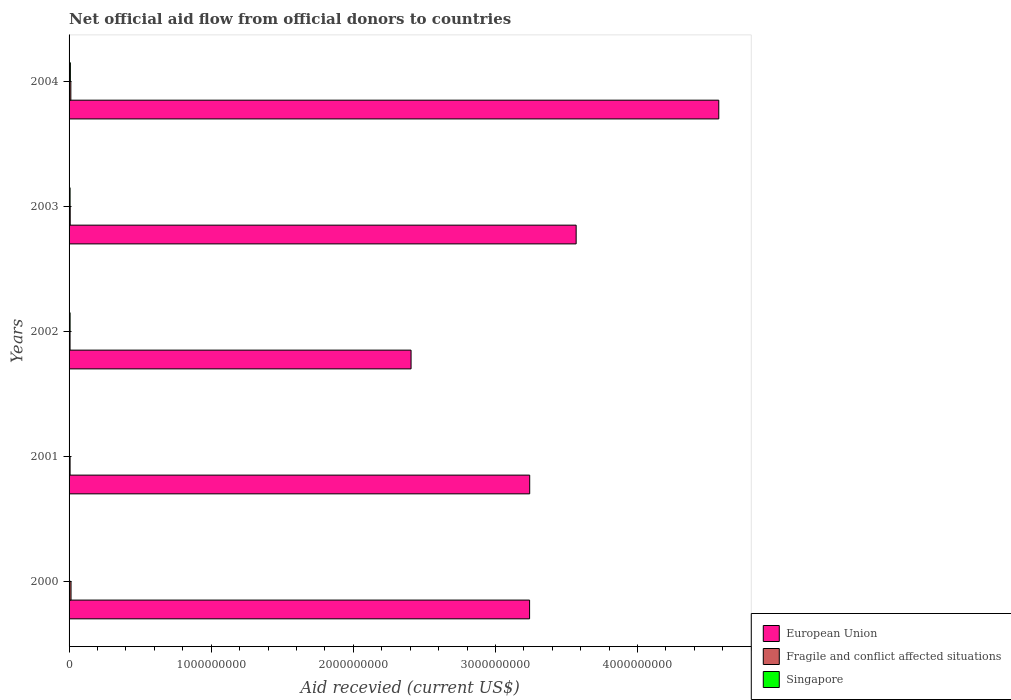Are the number of bars per tick equal to the number of legend labels?
Your answer should be compact. Yes. How many bars are there on the 2nd tick from the top?
Your answer should be very brief. 3. What is the total aid received in Fragile and conflict affected situations in 2004?
Your answer should be compact. 1.24e+07. Across all years, what is the maximum total aid received in European Union?
Your response must be concise. 4.57e+09. Across all years, what is the minimum total aid received in Fragile and conflict affected situations?
Your answer should be very brief. 6.88e+06. In which year was the total aid received in European Union maximum?
Your response must be concise. 2004. In which year was the total aid received in European Union minimum?
Your response must be concise. 2002. What is the total total aid received in Singapore in the graph?
Offer a terse response. 2.53e+07. What is the difference between the total aid received in European Union in 2000 and that in 2003?
Your answer should be compact. -3.28e+08. What is the difference between the total aid received in Fragile and conflict affected situations in 2000 and the total aid received in Singapore in 2003?
Ensure brevity in your answer.  6.68e+06. What is the average total aid received in Singapore per year?
Offer a terse response. 5.07e+06. In the year 2001, what is the difference between the total aid received in Singapore and total aid received in European Union?
Offer a terse response. -3.24e+09. What is the ratio of the total aid received in Singapore in 2001 to that in 2004?
Offer a terse response. 0.09. Is the total aid received in Fragile and conflict affected situations in 2000 less than that in 2002?
Ensure brevity in your answer.  No. Is the difference between the total aid received in Singapore in 2001 and 2004 greater than the difference between the total aid received in European Union in 2001 and 2004?
Make the answer very short. Yes. What is the difference between the highest and the second highest total aid received in European Union?
Ensure brevity in your answer.  1.00e+09. What is the difference between the highest and the lowest total aid received in Singapore?
Your answer should be compact. 8.29e+06. What does the 1st bar from the top in 2002 represents?
Give a very brief answer. Singapore. What does the 3rd bar from the bottom in 2003 represents?
Your response must be concise. Singapore. Is it the case that in every year, the sum of the total aid received in Singapore and total aid received in Fragile and conflict affected situations is greater than the total aid received in European Union?
Your answer should be compact. No. How many bars are there?
Keep it short and to the point. 15. What is the difference between two consecutive major ticks on the X-axis?
Your response must be concise. 1.00e+09. Does the graph contain any zero values?
Provide a short and direct response. No. How are the legend labels stacked?
Make the answer very short. Vertical. What is the title of the graph?
Your answer should be compact. Net official aid flow from official donors to countries. What is the label or title of the X-axis?
Offer a terse response. Aid recevied (current US$). What is the label or title of the Y-axis?
Your answer should be compact. Years. What is the Aid recevied (current US$) in European Union in 2000?
Your answer should be very brief. 3.24e+09. What is the Aid recevied (current US$) of Fragile and conflict affected situations in 2000?
Provide a succinct answer. 1.38e+07. What is the Aid recevied (current US$) in Singapore in 2000?
Your answer should be very brief. 1.09e+06. What is the Aid recevied (current US$) in European Union in 2001?
Offer a very short reply. 3.24e+09. What is the Aid recevied (current US$) in Fragile and conflict affected situations in 2001?
Provide a succinct answer. 7.14e+06. What is the Aid recevied (current US$) of Singapore in 2001?
Make the answer very short. 8.50e+05. What is the Aid recevied (current US$) of European Union in 2002?
Give a very brief answer. 2.41e+09. What is the Aid recevied (current US$) of Fragile and conflict affected situations in 2002?
Provide a short and direct response. 6.88e+06. What is the Aid recevied (current US$) in Singapore in 2002?
Your answer should be compact. 7.19e+06. What is the Aid recevied (current US$) of European Union in 2003?
Make the answer very short. 3.57e+09. What is the Aid recevied (current US$) in Fragile and conflict affected situations in 2003?
Your response must be concise. 7.95e+06. What is the Aid recevied (current US$) in Singapore in 2003?
Your answer should be very brief. 7.07e+06. What is the Aid recevied (current US$) of European Union in 2004?
Your response must be concise. 4.57e+09. What is the Aid recevied (current US$) of Fragile and conflict affected situations in 2004?
Provide a short and direct response. 1.24e+07. What is the Aid recevied (current US$) of Singapore in 2004?
Keep it short and to the point. 9.14e+06. Across all years, what is the maximum Aid recevied (current US$) in European Union?
Offer a very short reply. 4.57e+09. Across all years, what is the maximum Aid recevied (current US$) of Fragile and conflict affected situations?
Provide a short and direct response. 1.38e+07. Across all years, what is the maximum Aid recevied (current US$) of Singapore?
Ensure brevity in your answer.  9.14e+06. Across all years, what is the minimum Aid recevied (current US$) of European Union?
Offer a very short reply. 2.41e+09. Across all years, what is the minimum Aid recevied (current US$) in Fragile and conflict affected situations?
Your response must be concise. 6.88e+06. Across all years, what is the minimum Aid recevied (current US$) of Singapore?
Your answer should be compact. 8.50e+05. What is the total Aid recevied (current US$) in European Union in the graph?
Provide a short and direct response. 1.70e+1. What is the total Aid recevied (current US$) in Fragile and conflict affected situations in the graph?
Give a very brief answer. 4.82e+07. What is the total Aid recevied (current US$) in Singapore in the graph?
Make the answer very short. 2.53e+07. What is the difference between the Aid recevied (current US$) of European Union in 2000 and that in 2001?
Keep it short and to the point. -7.70e+05. What is the difference between the Aid recevied (current US$) in Fragile and conflict affected situations in 2000 and that in 2001?
Give a very brief answer. 6.61e+06. What is the difference between the Aid recevied (current US$) in Singapore in 2000 and that in 2001?
Your answer should be compact. 2.40e+05. What is the difference between the Aid recevied (current US$) in European Union in 2000 and that in 2002?
Offer a very short reply. 8.34e+08. What is the difference between the Aid recevied (current US$) in Fragile and conflict affected situations in 2000 and that in 2002?
Your response must be concise. 6.87e+06. What is the difference between the Aid recevied (current US$) in Singapore in 2000 and that in 2002?
Your answer should be very brief. -6.10e+06. What is the difference between the Aid recevied (current US$) of European Union in 2000 and that in 2003?
Provide a short and direct response. -3.28e+08. What is the difference between the Aid recevied (current US$) of Fragile and conflict affected situations in 2000 and that in 2003?
Offer a very short reply. 5.80e+06. What is the difference between the Aid recevied (current US$) in Singapore in 2000 and that in 2003?
Your response must be concise. -5.98e+06. What is the difference between the Aid recevied (current US$) of European Union in 2000 and that in 2004?
Offer a very short reply. -1.33e+09. What is the difference between the Aid recevied (current US$) in Fragile and conflict affected situations in 2000 and that in 2004?
Make the answer very short. 1.32e+06. What is the difference between the Aid recevied (current US$) of Singapore in 2000 and that in 2004?
Offer a terse response. -8.05e+06. What is the difference between the Aid recevied (current US$) in European Union in 2001 and that in 2002?
Offer a very short reply. 8.35e+08. What is the difference between the Aid recevied (current US$) in Fragile and conflict affected situations in 2001 and that in 2002?
Your response must be concise. 2.60e+05. What is the difference between the Aid recevied (current US$) of Singapore in 2001 and that in 2002?
Ensure brevity in your answer.  -6.34e+06. What is the difference between the Aid recevied (current US$) of European Union in 2001 and that in 2003?
Your answer should be very brief. -3.27e+08. What is the difference between the Aid recevied (current US$) in Fragile and conflict affected situations in 2001 and that in 2003?
Make the answer very short. -8.10e+05. What is the difference between the Aid recevied (current US$) of Singapore in 2001 and that in 2003?
Provide a short and direct response. -6.22e+06. What is the difference between the Aid recevied (current US$) in European Union in 2001 and that in 2004?
Give a very brief answer. -1.33e+09. What is the difference between the Aid recevied (current US$) of Fragile and conflict affected situations in 2001 and that in 2004?
Your response must be concise. -5.29e+06. What is the difference between the Aid recevied (current US$) in Singapore in 2001 and that in 2004?
Your response must be concise. -8.29e+06. What is the difference between the Aid recevied (current US$) of European Union in 2002 and that in 2003?
Provide a succinct answer. -1.16e+09. What is the difference between the Aid recevied (current US$) in Fragile and conflict affected situations in 2002 and that in 2003?
Offer a very short reply. -1.07e+06. What is the difference between the Aid recevied (current US$) in Singapore in 2002 and that in 2003?
Ensure brevity in your answer.  1.20e+05. What is the difference between the Aid recevied (current US$) of European Union in 2002 and that in 2004?
Ensure brevity in your answer.  -2.17e+09. What is the difference between the Aid recevied (current US$) in Fragile and conflict affected situations in 2002 and that in 2004?
Make the answer very short. -5.55e+06. What is the difference between the Aid recevied (current US$) of Singapore in 2002 and that in 2004?
Keep it short and to the point. -1.95e+06. What is the difference between the Aid recevied (current US$) in European Union in 2003 and that in 2004?
Give a very brief answer. -1.00e+09. What is the difference between the Aid recevied (current US$) in Fragile and conflict affected situations in 2003 and that in 2004?
Keep it short and to the point. -4.48e+06. What is the difference between the Aid recevied (current US$) of Singapore in 2003 and that in 2004?
Provide a short and direct response. -2.07e+06. What is the difference between the Aid recevied (current US$) in European Union in 2000 and the Aid recevied (current US$) in Fragile and conflict affected situations in 2001?
Keep it short and to the point. 3.23e+09. What is the difference between the Aid recevied (current US$) in European Union in 2000 and the Aid recevied (current US$) in Singapore in 2001?
Offer a terse response. 3.24e+09. What is the difference between the Aid recevied (current US$) of Fragile and conflict affected situations in 2000 and the Aid recevied (current US$) of Singapore in 2001?
Your answer should be very brief. 1.29e+07. What is the difference between the Aid recevied (current US$) in European Union in 2000 and the Aid recevied (current US$) in Fragile and conflict affected situations in 2002?
Make the answer very short. 3.23e+09. What is the difference between the Aid recevied (current US$) in European Union in 2000 and the Aid recevied (current US$) in Singapore in 2002?
Offer a very short reply. 3.23e+09. What is the difference between the Aid recevied (current US$) of Fragile and conflict affected situations in 2000 and the Aid recevied (current US$) of Singapore in 2002?
Ensure brevity in your answer.  6.56e+06. What is the difference between the Aid recevied (current US$) of European Union in 2000 and the Aid recevied (current US$) of Fragile and conflict affected situations in 2003?
Make the answer very short. 3.23e+09. What is the difference between the Aid recevied (current US$) of European Union in 2000 and the Aid recevied (current US$) of Singapore in 2003?
Provide a short and direct response. 3.23e+09. What is the difference between the Aid recevied (current US$) of Fragile and conflict affected situations in 2000 and the Aid recevied (current US$) of Singapore in 2003?
Ensure brevity in your answer.  6.68e+06. What is the difference between the Aid recevied (current US$) in European Union in 2000 and the Aid recevied (current US$) in Fragile and conflict affected situations in 2004?
Give a very brief answer. 3.23e+09. What is the difference between the Aid recevied (current US$) in European Union in 2000 and the Aid recevied (current US$) in Singapore in 2004?
Keep it short and to the point. 3.23e+09. What is the difference between the Aid recevied (current US$) of Fragile and conflict affected situations in 2000 and the Aid recevied (current US$) of Singapore in 2004?
Give a very brief answer. 4.61e+06. What is the difference between the Aid recevied (current US$) in European Union in 2001 and the Aid recevied (current US$) in Fragile and conflict affected situations in 2002?
Offer a very short reply. 3.23e+09. What is the difference between the Aid recevied (current US$) of European Union in 2001 and the Aid recevied (current US$) of Singapore in 2002?
Provide a succinct answer. 3.23e+09. What is the difference between the Aid recevied (current US$) in Fragile and conflict affected situations in 2001 and the Aid recevied (current US$) in Singapore in 2002?
Your answer should be compact. -5.00e+04. What is the difference between the Aid recevied (current US$) of European Union in 2001 and the Aid recevied (current US$) of Fragile and conflict affected situations in 2003?
Make the answer very short. 3.23e+09. What is the difference between the Aid recevied (current US$) of European Union in 2001 and the Aid recevied (current US$) of Singapore in 2003?
Ensure brevity in your answer.  3.23e+09. What is the difference between the Aid recevied (current US$) of Fragile and conflict affected situations in 2001 and the Aid recevied (current US$) of Singapore in 2003?
Keep it short and to the point. 7.00e+04. What is the difference between the Aid recevied (current US$) in European Union in 2001 and the Aid recevied (current US$) in Fragile and conflict affected situations in 2004?
Make the answer very short. 3.23e+09. What is the difference between the Aid recevied (current US$) of European Union in 2001 and the Aid recevied (current US$) of Singapore in 2004?
Give a very brief answer. 3.23e+09. What is the difference between the Aid recevied (current US$) of Fragile and conflict affected situations in 2001 and the Aid recevied (current US$) of Singapore in 2004?
Make the answer very short. -2.00e+06. What is the difference between the Aid recevied (current US$) in European Union in 2002 and the Aid recevied (current US$) in Fragile and conflict affected situations in 2003?
Offer a terse response. 2.40e+09. What is the difference between the Aid recevied (current US$) in European Union in 2002 and the Aid recevied (current US$) in Singapore in 2003?
Provide a succinct answer. 2.40e+09. What is the difference between the Aid recevied (current US$) in Fragile and conflict affected situations in 2002 and the Aid recevied (current US$) in Singapore in 2003?
Your answer should be very brief. -1.90e+05. What is the difference between the Aid recevied (current US$) of European Union in 2002 and the Aid recevied (current US$) of Fragile and conflict affected situations in 2004?
Your response must be concise. 2.39e+09. What is the difference between the Aid recevied (current US$) in European Union in 2002 and the Aid recevied (current US$) in Singapore in 2004?
Give a very brief answer. 2.40e+09. What is the difference between the Aid recevied (current US$) in Fragile and conflict affected situations in 2002 and the Aid recevied (current US$) in Singapore in 2004?
Make the answer very short. -2.26e+06. What is the difference between the Aid recevied (current US$) in European Union in 2003 and the Aid recevied (current US$) in Fragile and conflict affected situations in 2004?
Your response must be concise. 3.56e+09. What is the difference between the Aid recevied (current US$) of European Union in 2003 and the Aid recevied (current US$) of Singapore in 2004?
Provide a succinct answer. 3.56e+09. What is the difference between the Aid recevied (current US$) in Fragile and conflict affected situations in 2003 and the Aid recevied (current US$) in Singapore in 2004?
Give a very brief answer. -1.19e+06. What is the average Aid recevied (current US$) in European Union per year?
Provide a short and direct response. 3.41e+09. What is the average Aid recevied (current US$) in Fragile and conflict affected situations per year?
Give a very brief answer. 9.63e+06. What is the average Aid recevied (current US$) in Singapore per year?
Your response must be concise. 5.07e+06. In the year 2000, what is the difference between the Aid recevied (current US$) of European Union and Aid recevied (current US$) of Fragile and conflict affected situations?
Offer a very short reply. 3.23e+09. In the year 2000, what is the difference between the Aid recevied (current US$) of European Union and Aid recevied (current US$) of Singapore?
Make the answer very short. 3.24e+09. In the year 2000, what is the difference between the Aid recevied (current US$) of Fragile and conflict affected situations and Aid recevied (current US$) of Singapore?
Give a very brief answer. 1.27e+07. In the year 2001, what is the difference between the Aid recevied (current US$) in European Union and Aid recevied (current US$) in Fragile and conflict affected situations?
Your answer should be very brief. 3.23e+09. In the year 2001, what is the difference between the Aid recevied (current US$) in European Union and Aid recevied (current US$) in Singapore?
Your answer should be very brief. 3.24e+09. In the year 2001, what is the difference between the Aid recevied (current US$) in Fragile and conflict affected situations and Aid recevied (current US$) in Singapore?
Offer a terse response. 6.29e+06. In the year 2002, what is the difference between the Aid recevied (current US$) of European Union and Aid recevied (current US$) of Fragile and conflict affected situations?
Offer a very short reply. 2.40e+09. In the year 2002, what is the difference between the Aid recevied (current US$) in European Union and Aid recevied (current US$) in Singapore?
Provide a succinct answer. 2.40e+09. In the year 2002, what is the difference between the Aid recevied (current US$) in Fragile and conflict affected situations and Aid recevied (current US$) in Singapore?
Make the answer very short. -3.10e+05. In the year 2003, what is the difference between the Aid recevied (current US$) of European Union and Aid recevied (current US$) of Fragile and conflict affected situations?
Keep it short and to the point. 3.56e+09. In the year 2003, what is the difference between the Aid recevied (current US$) of European Union and Aid recevied (current US$) of Singapore?
Provide a short and direct response. 3.56e+09. In the year 2003, what is the difference between the Aid recevied (current US$) in Fragile and conflict affected situations and Aid recevied (current US$) in Singapore?
Your answer should be compact. 8.80e+05. In the year 2004, what is the difference between the Aid recevied (current US$) in European Union and Aid recevied (current US$) in Fragile and conflict affected situations?
Provide a succinct answer. 4.56e+09. In the year 2004, what is the difference between the Aid recevied (current US$) of European Union and Aid recevied (current US$) of Singapore?
Give a very brief answer. 4.56e+09. In the year 2004, what is the difference between the Aid recevied (current US$) in Fragile and conflict affected situations and Aid recevied (current US$) in Singapore?
Make the answer very short. 3.29e+06. What is the ratio of the Aid recevied (current US$) in Fragile and conflict affected situations in 2000 to that in 2001?
Make the answer very short. 1.93. What is the ratio of the Aid recevied (current US$) of Singapore in 2000 to that in 2001?
Give a very brief answer. 1.28. What is the ratio of the Aid recevied (current US$) in European Union in 2000 to that in 2002?
Provide a short and direct response. 1.35. What is the ratio of the Aid recevied (current US$) of Fragile and conflict affected situations in 2000 to that in 2002?
Offer a terse response. 2. What is the ratio of the Aid recevied (current US$) of Singapore in 2000 to that in 2002?
Keep it short and to the point. 0.15. What is the ratio of the Aid recevied (current US$) in European Union in 2000 to that in 2003?
Offer a terse response. 0.91. What is the ratio of the Aid recevied (current US$) in Fragile and conflict affected situations in 2000 to that in 2003?
Your answer should be compact. 1.73. What is the ratio of the Aid recevied (current US$) of Singapore in 2000 to that in 2003?
Make the answer very short. 0.15. What is the ratio of the Aid recevied (current US$) of European Union in 2000 to that in 2004?
Your answer should be compact. 0.71. What is the ratio of the Aid recevied (current US$) of Fragile and conflict affected situations in 2000 to that in 2004?
Make the answer very short. 1.11. What is the ratio of the Aid recevied (current US$) of Singapore in 2000 to that in 2004?
Provide a succinct answer. 0.12. What is the ratio of the Aid recevied (current US$) in European Union in 2001 to that in 2002?
Give a very brief answer. 1.35. What is the ratio of the Aid recevied (current US$) of Fragile and conflict affected situations in 2001 to that in 2002?
Ensure brevity in your answer.  1.04. What is the ratio of the Aid recevied (current US$) of Singapore in 2001 to that in 2002?
Provide a succinct answer. 0.12. What is the ratio of the Aid recevied (current US$) of European Union in 2001 to that in 2003?
Your response must be concise. 0.91. What is the ratio of the Aid recevied (current US$) in Fragile and conflict affected situations in 2001 to that in 2003?
Your answer should be compact. 0.9. What is the ratio of the Aid recevied (current US$) of Singapore in 2001 to that in 2003?
Make the answer very short. 0.12. What is the ratio of the Aid recevied (current US$) in European Union in 2001 to that in 2004?
Provide a short and direct response. 0.71. What is the ratio of the Aid recevied (current US$) in Fragile and conflict affected situations in 2001 to that in 2004?
Ensure brevity in your answer.  0.57. What is the ratio of the Aid recevied (current US$) in Singapore in 2001 to that in 2004?
Provide a succinct answer. 0.09. What is the ratio of the Aid recevied (current US$) in European Union in 2002 to that in 2003?
Ensure brevity in your answer.  0.67. What is the ratio of the Aid recevied (current US$) of Fragile and conflict affected situations in 2002 to that in 2003?
Give a very brief answer. 0.87. What is the ratio of the Aid recevied (current US$) in European Union in 2002 to that in 2004?
Your response must be concise. 0.53. What is the ratio of the Aid recevied (current US$) of Fragile and conflict affected situations in 2002 to that in 2004?
Your answer should be very brief. 0.55. What is the ratio of the Aid recevied (current US$) of Singapore in 2002 to that in 2004?
Your response must be concise. 0.79. What is the ratio of the Aid recevied (current US$) of European Union in 2003 to that in 2004?
Provide a succinct answer. 0.78. What is the ratio of the Aid recevied (current US$) of Fragile and conflict affected situations in 2003 to that in 2004?
Offer a terse response. 0.64. What is the ratio of the Aid recevied (current US$) of Singapore in 2003 to that in 2004?
Make the answer very short. 0.77. What is the difference between the highest and the second highest Aid recevied (current US$) in European Union?
Your answer should be compact. 1.00e+09. What is the difference between the highest and the second highest Aid recevied (current US$) in Fragile and conflict affected situations?
Your answer should be compact. 1.32e+06. What is the difference between the highest and the second highest Aid recevied (current US$) in Singapore?
Ensure brevity in your answer.  1.95e+06. What is the difference between the highest and the lowest Aid recevied (current US$) of European Union?
Keep it short and to the point. 2.17e+09. What is the difference between the highest and the lowest Aid recevied (current US$) in Fragile and conflict affected situations?
Make the answer very short. 6.87e+06. What is the difference between the highest and the lowest Aid recevied (current US$) in Singapore?
Provide a short and direct response. 8.29e+06. 